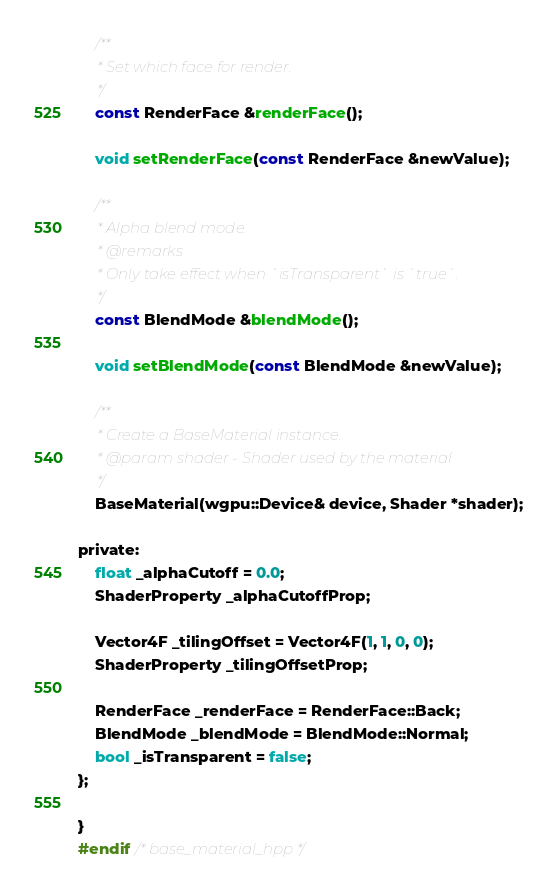<code> <loc_0><loc_0><loc_500><loc_500><_C_>    /**
     * Set which face for render.
     */
    const RenderFace &renderFace();
    
    void setRenderFace(const RenderFace &newValue);
    
    /**
     * Alpha blend mode.
     * @remarks
     * Only take effect when `isTransparent` is `true`.
     */
    const BlendMode &blendMode();
    
    void setBlendMode(const BlendMode &newValue);
    
    /**
     * Create a BaseMaterial instance.
     * @param shader - Shader used by the material
     */
    BaseMaterial(wgpu::Device& device, Shader *shader);
    
private:
    float _alphaCutoff = 0.0;
    ShaderProperty _alphaCutoffProp;
    
    Vector4F _tilingOffset = Vector4F(1, 1, 0, 0);
    ShaderProperty _tilingOffsetProp;
    
    RenderFace _renderFace = RenderFace::Back;
    BlendMode _blendMode = BlendMode::Normal;
    bool _isTransparent = false;
};

}
#endif /* base_material_hpp */
</code> 